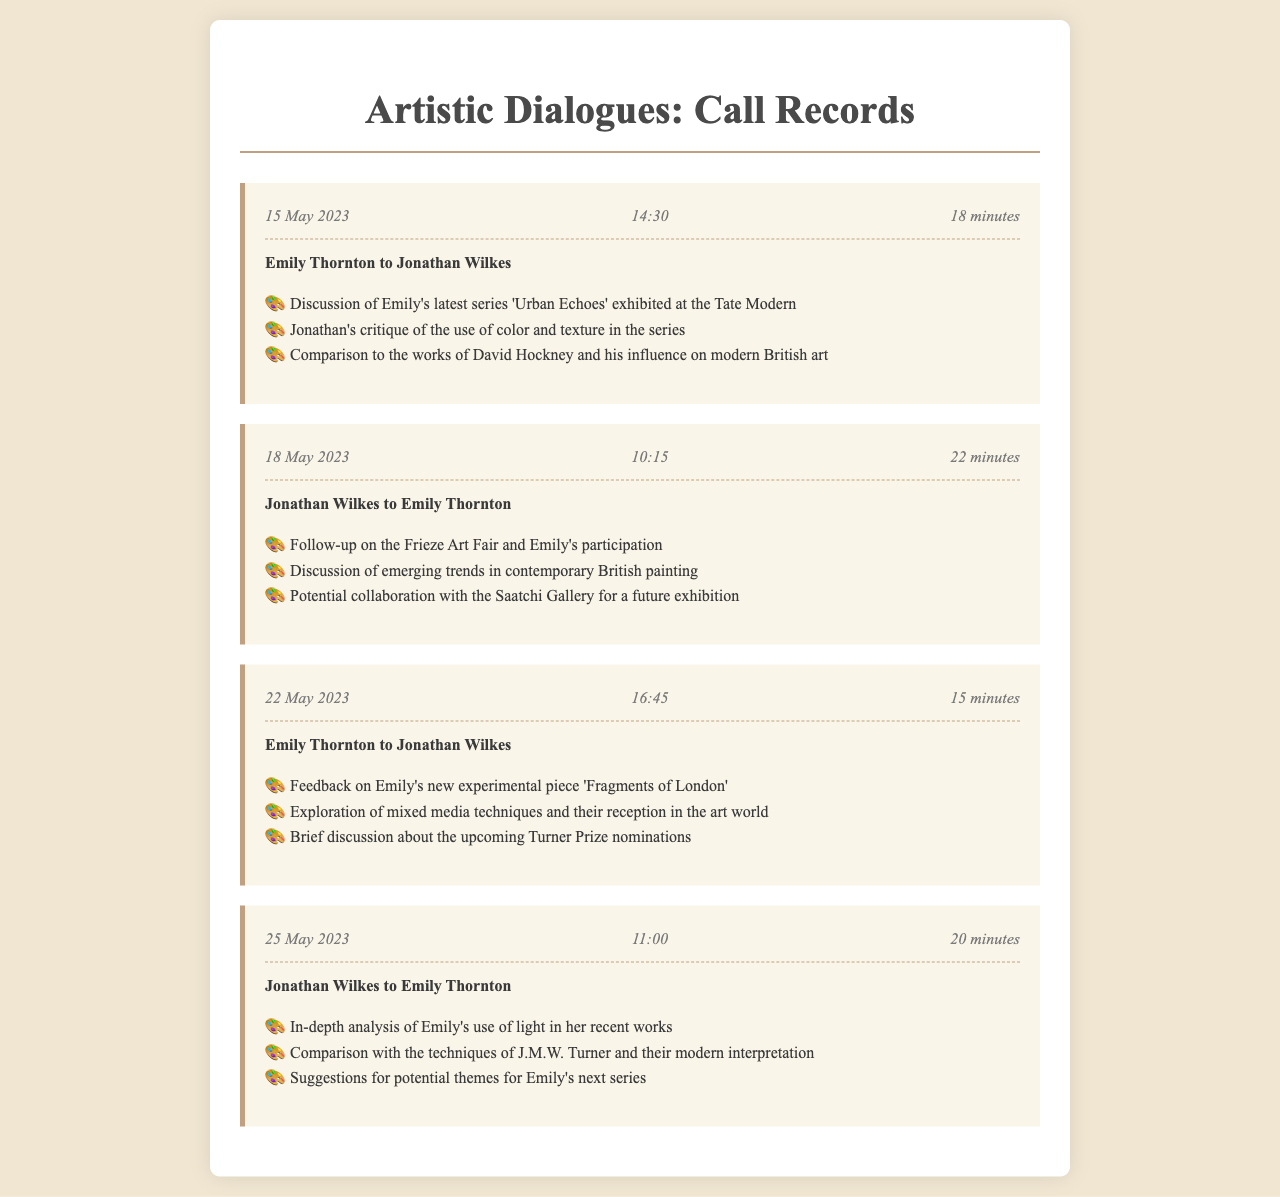What is the date of the first call? The date of the first call is mentioned at the beginning of the first call record.
Answer: 15 May 2023 Who initiated the call on 18 May 2023? The call on 18 May 2023 was initiated by Jonathan Wilkes, as stated in the call record.
Answer: Jonathan Wilkes What is the duration of the call on 22 May 2023? The duration of the call on 22 May 2023 is specified in the call record as part of the call header.
Answer: 15 minutes Which artwork did Emily receive feedback on during the call on 22 May 2023? The artwork Emily received feedback on is explicitly mentioned in the topics list of the relevant call record.
Answer: 'Fragments of London' What was a potential topic for Emily's next series discussed in the call on 25 May 2023? The potential themes for Emily's next series are included in the list of topics covered in the call record.
Answer: Suggestions for potential themes Which gallery was mentioned for a potential collaboration in the call on 18 May 2023? The gallery mentioned for a potential collaboration is documented in the topics covered during that call.
Answer: Saatchi Gallery What trend was discussed in the call on 18 May 2023? The emerging trends in contemporary British painting were discussed, as indicated in the topics list.
Answer: Emerging trends How long is the second call that Emily had with Jonathan? The duration of the second call is noted within the call record nested in the call header.
Answer: 22 minutes 